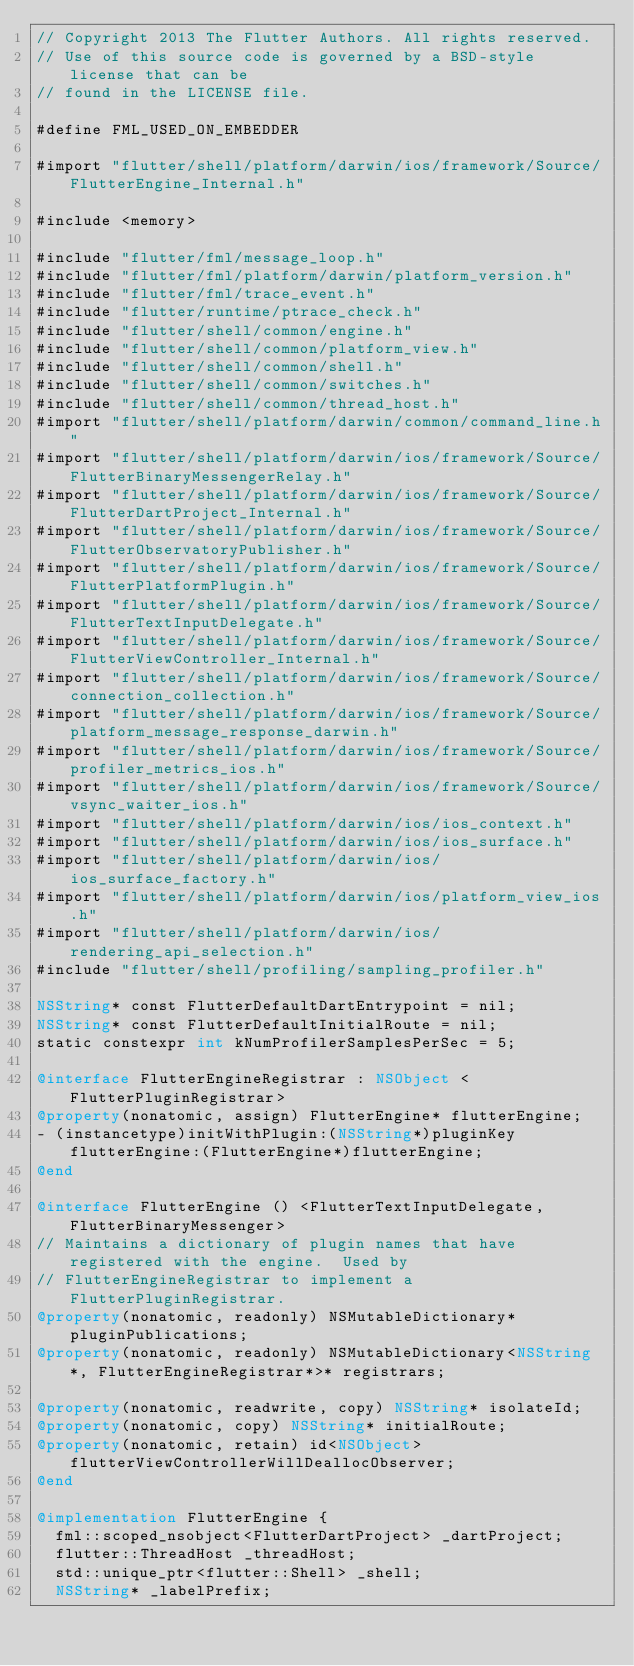Convert code to text. <code><loc_0><loc_0><loc_500><loc_500><_ObjectiveC_>// Copyright 2013 The Flutter Authors. All rights reserved.
// Use of this source code is governed by a BSD-style license that can be
// found in the LICENSE file.

#define FML_USED_ON_EMBEDDER

#import "flutter/shell/platform/darwin/ios/framework/Source/FlutterEngine_Internal.h"

#include <memory>

#include "flutter/fml/message_loop.h"
#include "flutter/fml/platform/darwin/platform_version.h"
#include "flutter/fml/trace_event.h"
#include "flutter/runtime/ptrace_check.h"
#include "flutter/shell/common/engine.h"
#include "flutter/shell/common/platform_view.h"
#include "flutter/shell/common/shell.h"
#include "flutter/shell/common/switches.h"
#include "flutter/shell/common/thread_host.h"
#import "flutter/shell/platform/darwin/common/command_line.h"
#import "flutter/shell/platform/darwin/ios/framework/Source/FlutterBinaryMessengerRelay.h"
#import "flutter/shell/platform/darwin/ios/framework/Source/FlutterDartProject_Internal.h"
#import "flutter/shell/platform/darwin/ios/framework/Source/FlutterObservatoryPublisher.h"
#import "flutter/shell/platform/darwin/ios/framework/Source/FlutterPlatformPlugin.h"
#import "flutter/shell/platform/darwin/ios/framework/Source/FlutterTextInputDelegate.h"
#import "flutter/shell/platform/darwin/ios/framework/Source/FlutterViewController_Internal.h"
#import "flutter/shell/platform/darwin/ios/framework/Source/connection_collection.h"
#import "flutter/shell/platform/darwin/ios/framework/Source/platform_message_response_darwin.h"
#import "flutter/shell/platform/darwin/ios/framework/Source/profiler_metrics_ios.h"
#import "flutter/shell/platform/darwin/ios/framework/Source/vsync_waiter_ios.h"
#import "flutter/shell/platform/darwin/ios/ios_context.h"
#import "flutter/shell/platform/darwin/ios/ios_surface.h"
#import "flutter/shell/platform/darwin/ios/ios_surface_factory.h"
#import "flutter/shell/platform/darwin/ios/platform_view_ios.h"
#import "flutter/shell/platform/darwin/ios/rendering_api_selection.h"
#include "flutter/shell/profiling/sampling_profiler.h"

NSString* const FlutterDefaultDartEntrypoint = nil;
NSString* const FlutterDefaultInitialRoute = nil;
static constexpr int kNumProfilerSamplesPerSec = 5;

@interface FlutterEngineRegistrar : NSObject <FlutterPluginRegistrar>
@property(nonatomic, assign) FlutterEngine* flutterEngine;
- (instancetype)initWithPlugin:(NSString*)pluginKey flutterEngine:(FlutterEngine*)flutterEngine;
@end

@interface FlutterEngine () <FlutterTextInputDelegate, FlutterBinaryMessenger>
// Maintains a dictionary of plugin names that have registered with the engine.  Used by
// FlutterEngineRegistrar to implement a FlutterPluginRegistrar.
@property(nonatomic, readonly) NSMutableDictionary* pluginPublications;
@property(nonatomic, readonly) NSMutableDictionary<NSString*, FlutterEngineRegistrar*>* registrars;

@property(nonatomic, readwrite, copy) NSString* isolateId;
@property(nonatomic, copy) NSString* initialRoute;
@property(nonatomic, retain) id<NSObject> flutterViewControllerWillDeallocObserver;
@end

@implementation FlutterEngine {
  fml::scoped_nsobject<FlutterDartProject> _dartProject;
  flutter::ThreadHost _threadHost;
  std::unique_ptr<flutter::Shell> _shell;
  NSString* _labelPrefix;</code> 